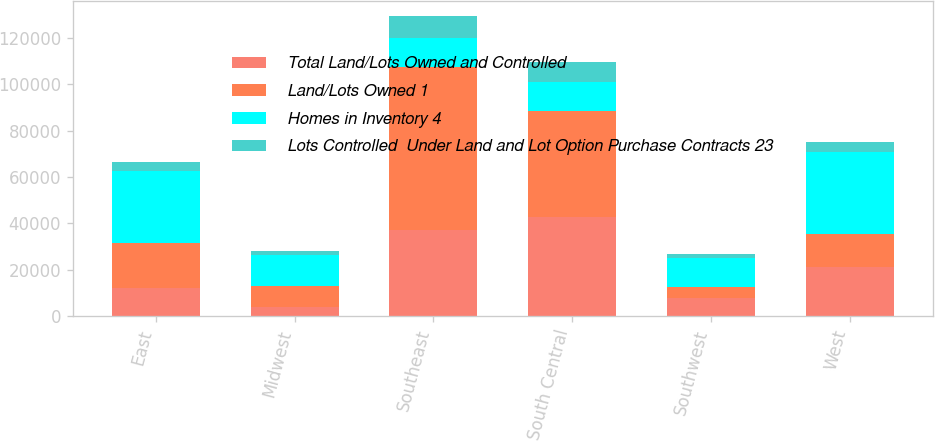Convert chart to OTSL. <chart><loc_0><loc_0><loc_500><loc_500><stacked_bar_chart><ecel><fcel>East<fcel>Midwest<fcel>Southeast<fcel>South Central<fcel>Southwest<fcel>West<nl><fcel>Total Land/Lots Owned and Controlled<fcel>11900<fcel>3800<fcel>37100<fcel>42900<fcel>7600<fcel>21000<nl><fcel>Land/Lots Owned 1<fcel>19400<fcel>9300<fcel>70400<fcel>45700<fcel>5000<fcel>14400<nl><fcel>Homes in Inventory 4<fcel>31300<fcel>13100<fcel>12250<fcel>12250<fcel>12600<fcel>35400<nl><fcel>Lots Controlled  Under Land and Lot Option Purchase Contracts 23<fcel>4000<fcel>1800<fcel>9500<fcel>8800<fcel>1500<fcel>4100<nl></chart> 